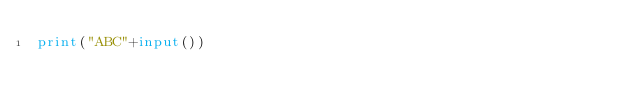Convert code to text. <code><loc_0><loc_0><loc_500><loc_500><_Python_>print("ABC"+input())</code> 